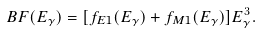<formula> <loc_0><loc_0><loc_500><loc_500>B F ( E _ { \gamma } ) = [ f _ { E 1 } ( E _ { \gamma } ) + f _ { M 1 } ( E _ { \gamma } ) ] E _ { \gamma } ^ { 3 } .</formula> 